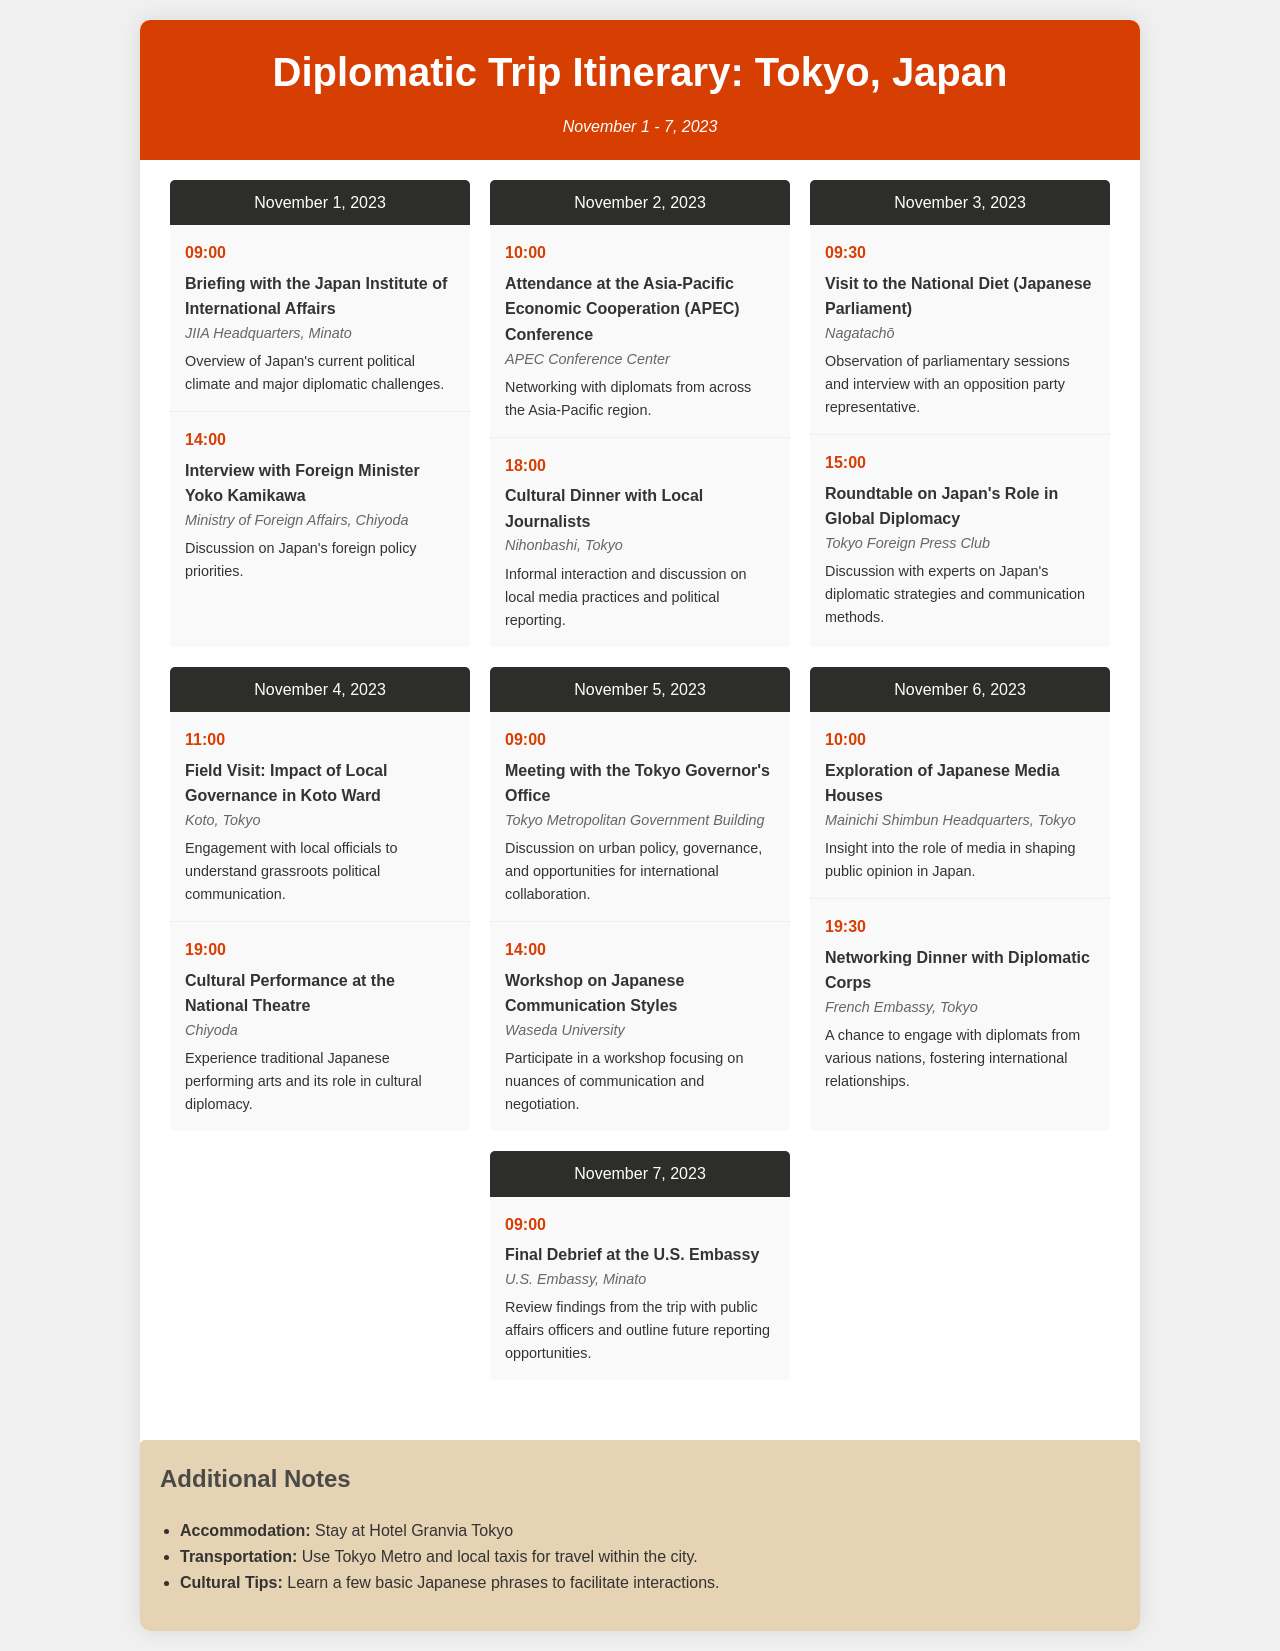What is the title of the document? The title is stated at the top of the document within the header section.
Answer: Diplomatic Trip Itinerary: Tokyo, Japan What is the date range of the trip? The date range is indicated right below the title in the document.
Answer: November 1 - 7, 2023 How many events are scheduled for November 3, 2023? The document lists the events under each day, allowing us to count the events for that specific date.
Answer: 2 Who is being interviewed on November 1, 2023? The name of the person being interviewed is mentioned in the event description for that date.
Answer: Foreign Minister Yoko Kamikawa What is the main focus of the workshop on November 5, 2023? The workshop's description provides insight into its content and purpose.
Answer: Japanese Communication Styles What cultural event is happening on November 4, 2023? The cultural performance is listed among the events scheduled for that date.
Answer: Cultural Performance at the National Theatre What is one transportation method mentioned for getting around Tokyo? The document notes transportation methods in the additional notes section.
Answer: Tokyo Metro What time does the final debrief at the U.S. Embassy start? The time for this event is captured in the schedule for that date.
Answer: 09:00 